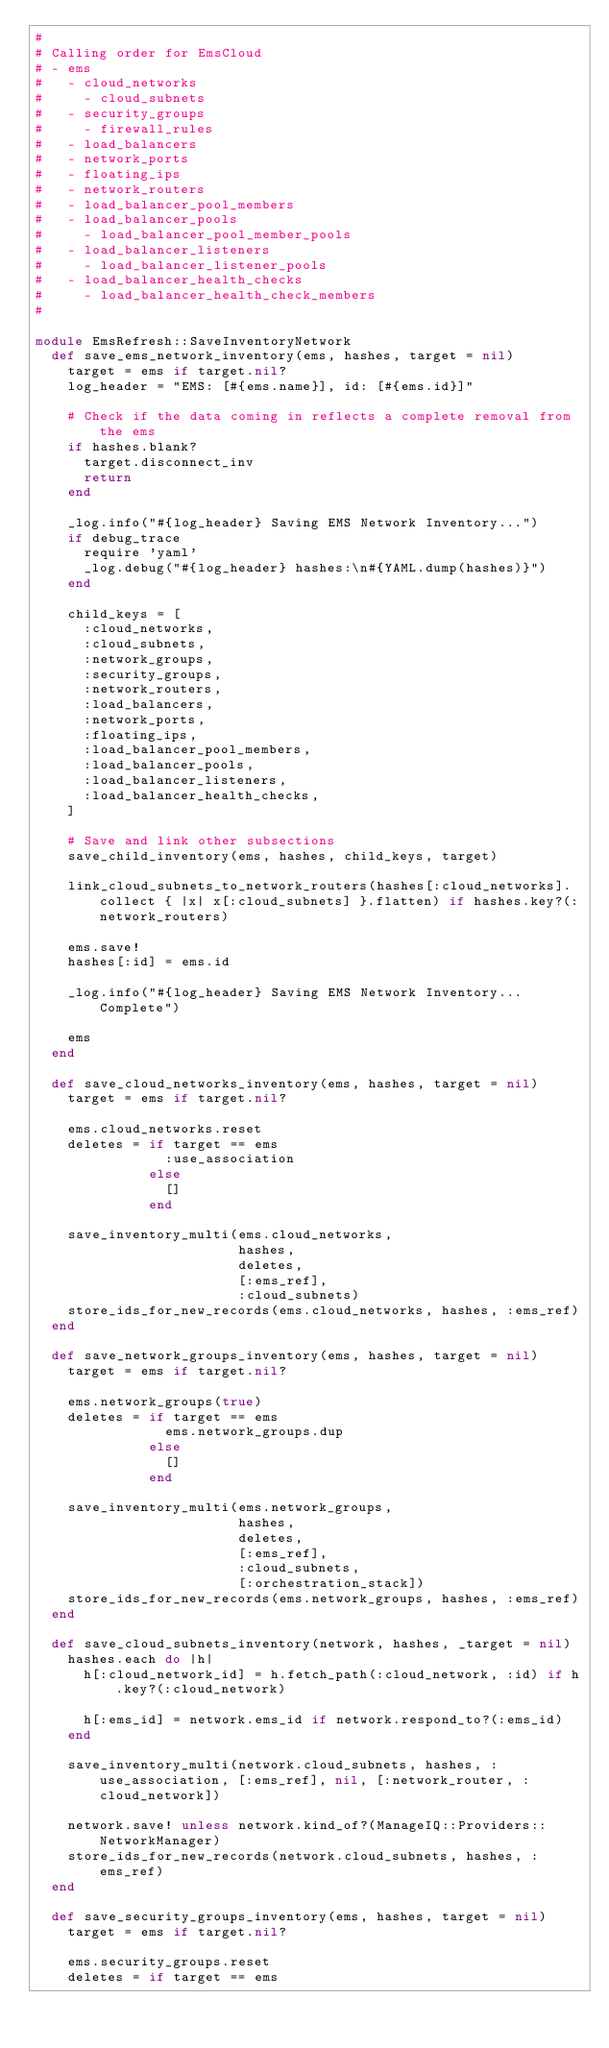<code> <loc_0><loc_0><loc_500><loc_500><_Ruby_>#
# Calling order for EmsCloud
# - ems
#   - cloud_networks
#     - cloud_subnets
#   - security_groups
#     - firewall_rules
#   - load_balancers
#   - network_ports
#   - floating_ips
#   - network_routers
#   - load_balancer_pool_members
#   - load_balancer_pools
#     - load_balancer_pool_member_pools
#   - load_balancer_listeners
#     - load_balancer_listener_pools
#   - load_balancer_health_checks
#     - load_balancer_health_check_members
#

module EmsRefresh::SaveInventoryNetwork
  def save_ems_network_inventory(ems, hashes, target = nil)
    target = ems if target.nil?
    log_header = "EMS: [#{ems.name}], id: [#{ems.id}]"

    # Check if the data coming in reflects a complete removal from the ems
    if hashes.blank?
      target.disconnect_inv
      return
    end

    _log.info("#{log_header} Saving EMS Network Inventory...")
    if debug_trace
      require 'yaml'
      _log.debug("#{log_header} hashes:\n#{YAML.dump(hashes)}")
    end

    child_keys = [
      :cloud_networks,
      :cloud_subnets,
      :network_groups,
      :security_groups,
      :network_routers,
      :load_balancers,
      :network_ports,
      :floating_ips,
      :load_balancer_pool_members,
      :load_balancer_pools,
      :load_balancer_listeners,
      :load_balancer_health_checks,
    ]

    # Save and link other subsections
    save_child_inventory(ems, hashes, child_keys, target)

    link_cloud_subnets_to_network_routers(hashes[:cloud_networks].collect { |x| x[:cloud_subnets] }.flatten) if hashes.key?(:network_routers)

    ems.save!
    hashes[:id] = ems.id

    _log.info("#{log_header} Saving EMS Network Inventory...Complete")

    ems
  end

  def save_cloud_networks_inventory(ems, hashes, target = nil)
    target = ems if target.nil?

    ems.cloud_networks.reset
    deletes = if target == ems
                :use_association
              else
                []
              end

    save_inventory_multi(ems.cloud_networks,
                         hashes,
                         deletes,
                         [:ems_ref],
                         :cloud_subnets)
    store_ids_for_new_records(ems.cloud_networks, hashes, :ems_ref)
  end

  def save_network_groups_inventory(ems, hashes, target = nil)
    target = ems if target.nil?

    ems.network_groups(true)
    deletes = if target == ems
                ems.network_groups.dup
              else
                []
              end

    save_inventory_multi(ems.network_groups,
                         hashes,
                         deletes,
                         [:ems_ref],
                         :cloud_subnets,
                         [:orchestration_stack])
    store_ids_for_new_records(ems.network_groups, hashes, :ems_ref)
  end

  def save_cloud_subnets_inventory(network, hashes, _target = nil)
    hashes.each do |h|
      h[:cloud_network_id] = h.fetch_path(:cloud_network, :id) if h.key?(:cloud_network)

      h[:ems_id] = network.ems_id if network.respond_to?(:ems_id)
    end

    save_inventory_multi(network.cloud_subnets, hashes, :use_association, [:ems_ref], nil, [:network_router, :cloud_network])

    network.save! unless network.kind_of?(ManageIQ::Providers::NetworkManager)
    store_ids_for_new_records(network.cloud_subnets, hashes, :ems_ref)
  end

  def save_security_groups_inventory(ems, hashes, target = nil)
    target = ems if target.nil?

    ems.security_groups.reset
    deletes = if target == ems</code> 